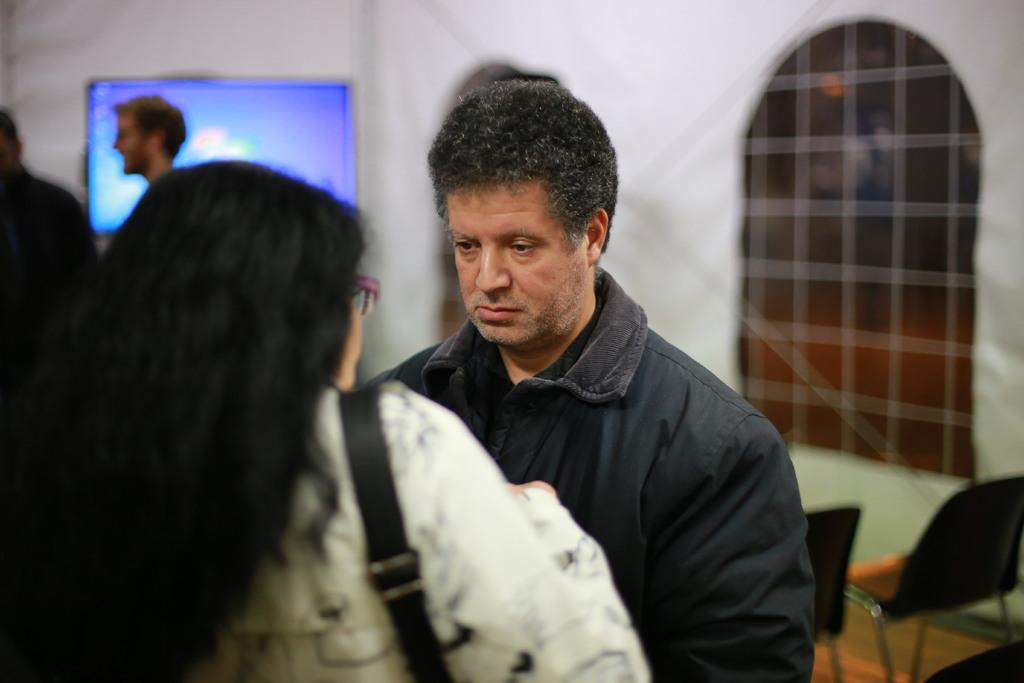How many people are in the image? There is a group of persons in the image. Where are the persons located in the image? The persons are standing in a room. What can be seen in the background of the image? There is a screen, a wall, and chairs in the background of the image. What type of trail can be seen in the image? There is no trail present in the image; it features a group of persons standing in a room with a screen, a wall, and chairs in the background. 